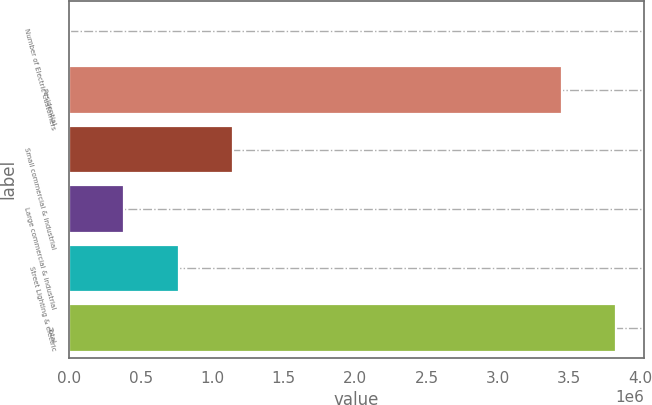Convert chart. <chart><loc_0><loc_0><loc_500><loc_500><bar_chart><fcel>Number of Electric Customers<fcel>Residential<fcel>Small commercial & industrial<fcel>Large commercial & industrial<fcel>Street Lighting & electric<fcel>Total<nl><fcel>2011<fcel>3.44848e+06<fcel>1.14775e+06<fcel>383923<fcel>765836<fcel>3.83039e+06<nl></chart> 